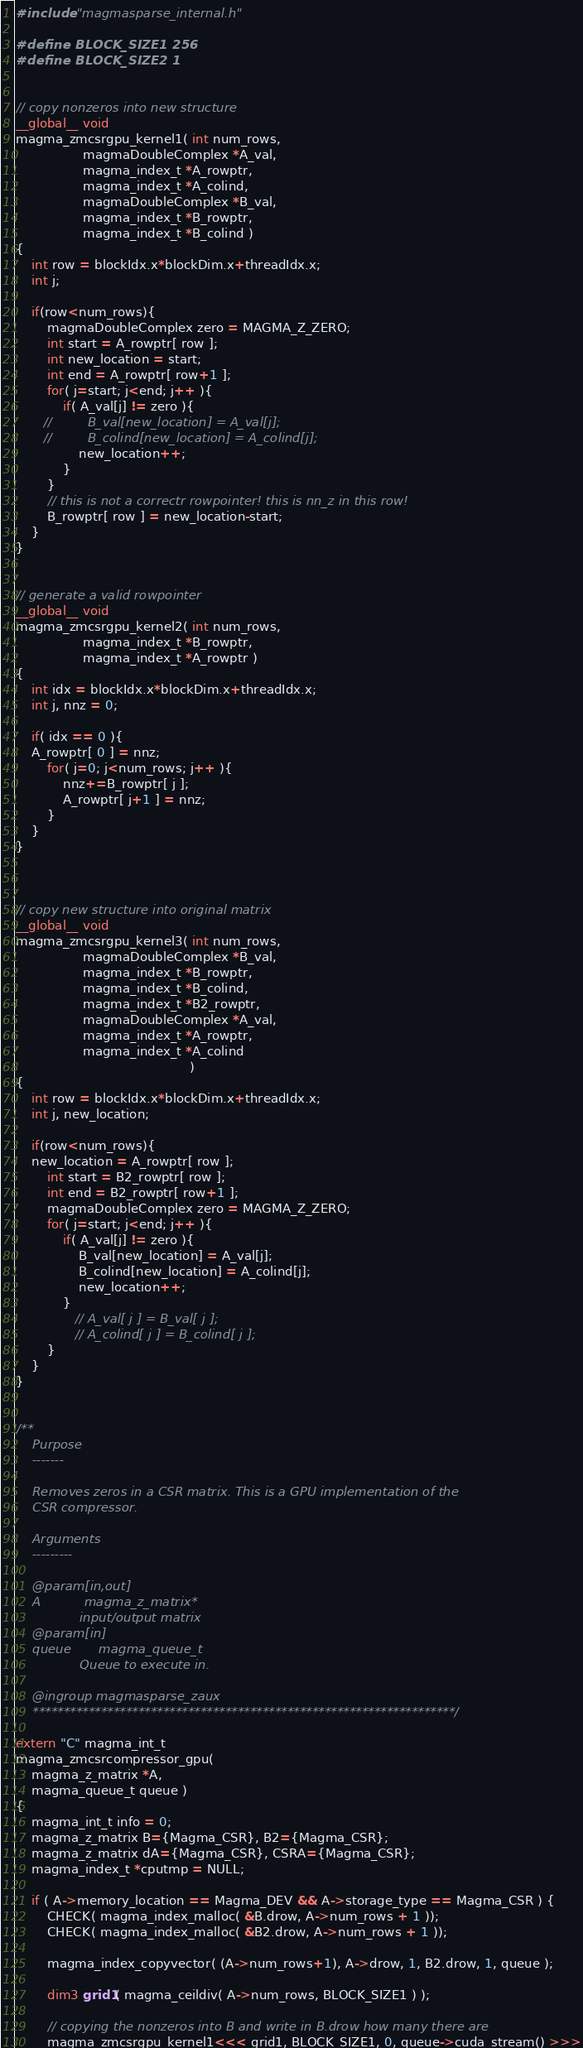<code> <loc_0><loc_0><loc_500><loc_500><_Cuda_>#include "magmasparse_internal.h"

#define BLOCK_SIZE1 256
#define BLOCK_SIZE2 1


// copy nonzeros into new structure
__global__ void
magma_zmcsrgpu_kernel1( int num_rows,
                 magmaDoubleComplex *A_val,
                 magma_index_t *A_rowptr,
                 magma_index_t *A_colind,
                 magmaDoubleComplex *B_val,
                 magma_index_t *B_rowptr,
                 magma_index_t *B_colind )
{
    int row = blockIdx.x*blockDim.x+threadIdx.x;
    int j;

    if(row<num_rows){
        magmaDoubleComplex zero = MAGMA_Z_ZERO;
        int start = A_rowptr[ row ];
        int new_location = start;
        int end = A_rowptr[ row+1 ];
        for( j=start; j<end; j++ ){
            if( A_val[j] != zero ){
       //         B_val[new_location] = A_val[j];
       //         B_colind[new_location] = A_colind[j];
                new_location++;
            }
        }
        // this is not a correctr rowpointer! this is nn_z in this row!
        B_rowptr[ row ] = new_location-start;
    }
}


// generate a valid rowpointer
__global__ void
magma_zmcsrgpu_kernel2( int num_rows,
                 magma_index_t *B_rowptr,
                 magma_index_t *A_rowptr )
{
    int idx = blockIdx.x*blockDim.x+threadIdx.x;
    int j, nnz = 0;

    if( idx == 0 ){
    A_rowptr[ 0 ] = nnz;
        for( j=0; j<num_rows; j++ ){
            nnz+=B_rowptr[ j ];
            A_rowptr[ j+1 ] = nnz;
        }
    }
}



// copy new structure into original matrix
__global__ void
magma_zmcsrgpu_kernel3( int num_rows,
                 magmaDoubleComplex *B_val,
                 magma_index_t *B_rowptr,
                 magma_index_t *B_colind,
                 magma_index_t *B2_rowptr,
                 magmaDoubleComplex *A_val,
                 magma_index_t *A_rowptr,
                 magma_index_t *A_colind
                                            )
{
    int row = blockIdx.x*blockDim.x+threadIdx.x;
    int j, new_location;
    
    if(row<num_rows){
    new_location = A_rowptr[ row ];
        int start = B2_rowptr[ row ];
        int end = B2_rowptr[ row+1 ];
        magmaDoubleComplex zero = MAGMA_Z_ZERO;
        for( j=start; j<end; j++ ){
            if( A_val[j] != zero ){
                B_val[new_location] = A_val[j];
                B_colind[new_location] = A_colind[j];
                new_location++;
            }
               // A_val[ j ] = B_val[ j ];
               // A_colind[ j ] = B_colind[ j ];
        }
    }
}


/**
    Purpose
    -------

    Removes zeros in a CSR matrix. This is a GPU implementation of the
    CSR compressor.

    Arguments
    ---------

    @param[in,out]
    A           magma_z_matrix*
                input/output matrix
    @param[in]
    queue       magma_queue_t
                Queue to execute in.

    @ingroup magmasparse_zaux
    ********************************************************************/

extern "C" magma_int_t
magma_zmcsrcompressor_gpu(
    magma_z_matrix *A,
    magma_queue_t queue )
{
    magma_int_t info = 0;
    magma_z_matrix B={Magma_CSR}, B2={Magma_CSR};
    magma_z_matrix dA={Magma_CSR}, CSRA={Magma_CSR};
    magma_index_t *cputmp = NULL;
    
    if ( A->memory_location == Magma_DEV && A->storage_type == Magma_CSR ) {
        CHECK( magma_index_malloc( &B.drow, A->num_rows + 1 ));
        CHECK( magma_index_malloc( &B2.drow, A->num_rows + 1 ));
        
        magma_index_copyvector( (A->num_rows+1), A->drow, 1, B2.drow, 1, queue );

        dim3 grid1( magma_ceildiv( A->num_rows, BLOCK_SIZE1 ) );

        // copying the nonzeros into B and write in B.drow how many there are
        magma_zmcsrgpu_kernel1<<< grid1, BLOCK_SIZE1, 0, queue->cuda_stream() >>></code> 